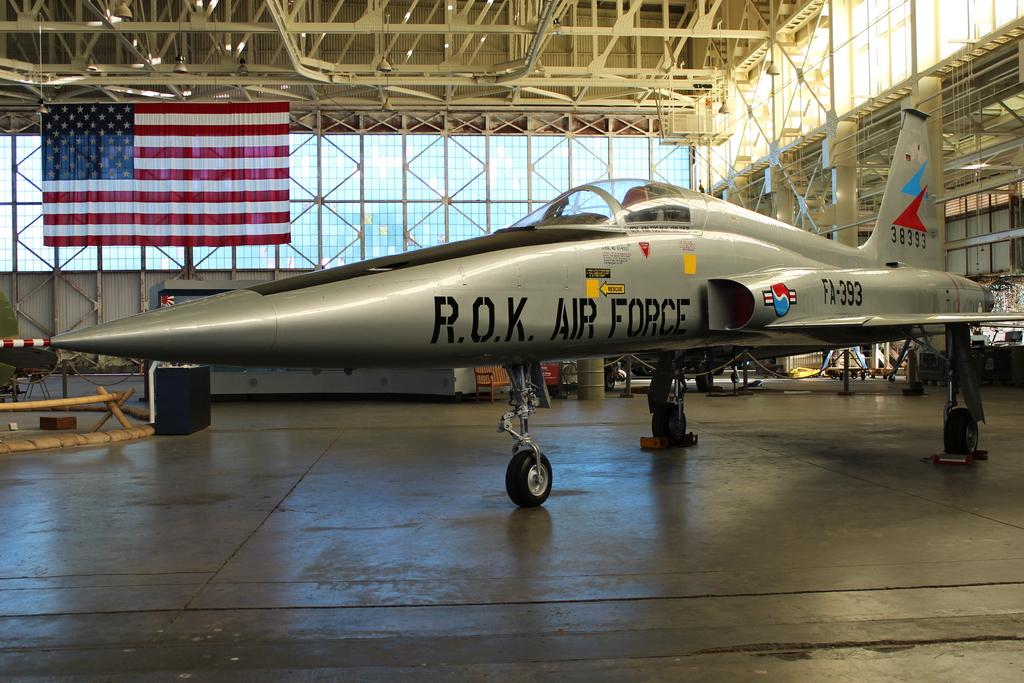What air force is on the plane?
Offer a very short reply. R.o.k. 